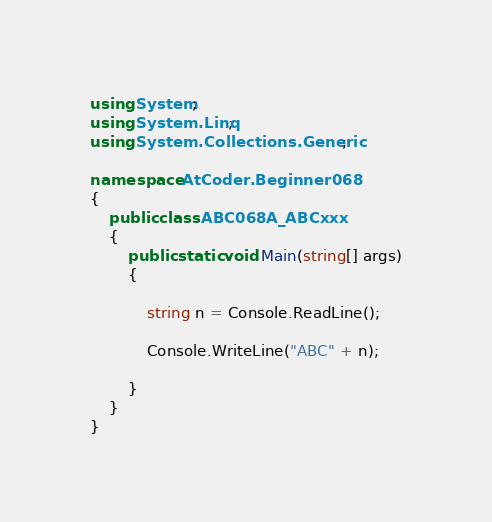Convert code to text. <code><loc_0><loc_0><loc_500><loc_500><_C#_>using System;
using System.Linq;
using System.Collections.Generic;

namespace AtCoder.Beginner068
{
    public class ABC068A_ABCxxx
    {
        public static void Main(string[] args)
        {
            
            string n = Console.ReadLine();

            Console.WriteLine("ABC" + n);

        }
    }
}</code> 